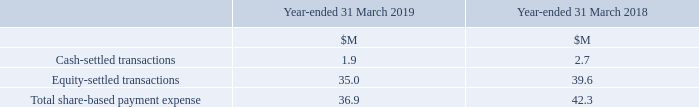Share-Based Payment Expense
The expense recognised for employee services received during the year is as follows:
The cash-settled expense comprises cash-based awards together with certain social security taxes. The carrying value of the liability as at 31 March 2019 was $1.6M (2018: $3.1M).
What was the carrying value of the liability in 2019? $1.6m. What was the  Cash-settled transactions for 2019?
Answer scale should be: million. 1.9. What are the types of transactions factored in the calculation of the total share-based payment expense recognised for employee services received during the year? Cash-settled transactions, equity-settled transactions. In which year was the Cash-settled transactions larger? 2.7>1.9
Answer: 2018. What was the change in Cash-settled transactions in 2019 from 2018?
Answer scale should be: million. 1.9-2.7
Answer: -0.8. What was the percentage change in Cash-settled transactions in 2019 from 2018?
Answer scale should be: percent. (1.9-2.7)/2.7
Answer: -29.63. 